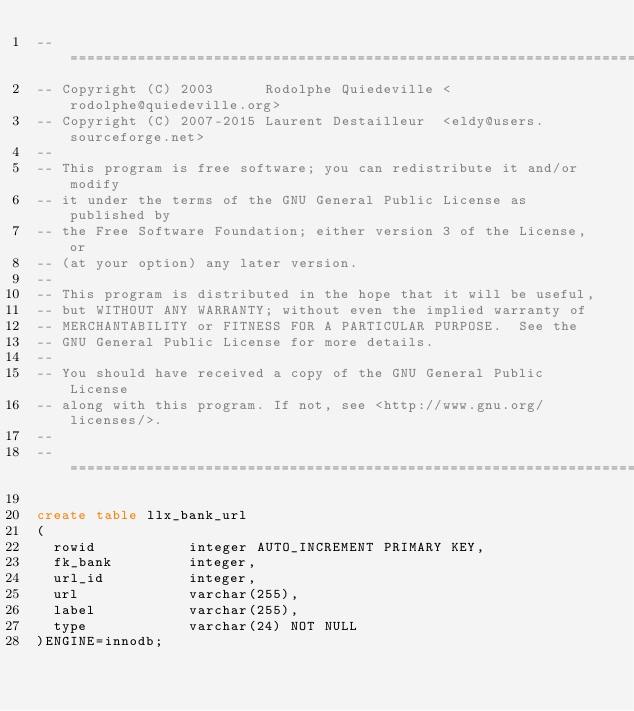<code> <loc_0><loc_0><loc_500><loc_500><_SQL_>-- ===================================================================
-- Copyright (C) 2003      Rodolphe Quiedeville <rodolphe@quiedeville.org>
-- Copyright (C) 2007-2015 Laurent Destailleur  <eldy@users.sourceforge.net>
--
-- This program is free software; you can redistribute it and/or modify
-- it under the terms of the GNU General Public License as published by
-- the Free Software Foundation; either version 3 of the License, or
-- (at your option) any later version.
--
-- This program is distributed in the hope that it will be useful,
-- but WITHOUT ANY WARRANTY; without even the implied warranty of
-- MERCHANTABILITY or FITNESS FOR A PARTICULAR PURPOSE.  See the
-- GNU General Public License for more details.
--
-- You should have received a copy of the GNU General Public License
-- along with this program. If not, see <http://www.gnu.org/licenses/>.
--
-- ===================================================================

create table llx_bank_url
(
  rowid           integer AUTO_INCREMENT PRIMARY KEY,
  fk_bank         integer,
  url_id          integer,
  url             varchar(255),
  label           varchar(255),
  type            varchar(24) NOT NULL
)ENGINE=innodb;
</code> 